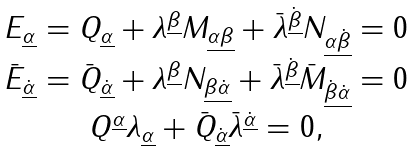<formula> <loc_0><loc_0><loc_500><loc_500>\begin{array} { c } E _ { \underline { \alpha } } = Q _ { \underline { \alpha } } + \lambda ^ { \underline { \beta } } M _ { \underline { \alpha \beta } } + \bar { \lambda } ^ { \underline { \dot { \beta } } } N _ { \underline { \alpha \dot { \beta } } } = 0 \\ \bar { E } _ { \underline { \dot { \alpha } } } = \bar { Q } _ { \underline { \dot { \alpha } } } + \lambda ^ { \underline { \beta } } N _ { \underline { \beta \dot { \alpha } } } + \bar { \lambda } ^ { \underline { \dot { \beta } } } \bar { M } _ { \underline { \dot { \beta } \dot { \alpha } } } = 0 \\ Q ^ { \underline { \alpha } } \lambda _ { \underline { \alpha } } + \bar { Q } _ { \underline { \dot { \alpha } } } \bar { \lambda } ^ { \underline { \dot { \alpha } } } = 0 , \end{array}</formula> 